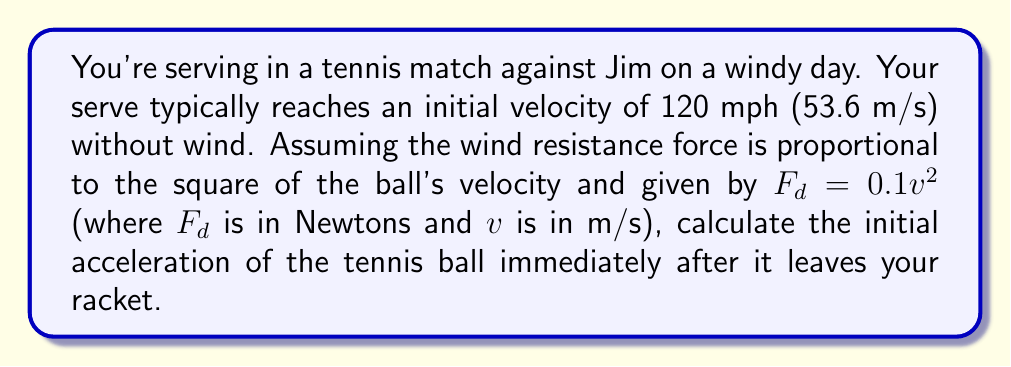Solve this math problem. To solve this problem, we'll follow these steps:

1) First, recall Newton's Second Law: $F = ma$

2) In this case, there are two forces acting on the ball:
   - The initial force of the serve ($F_s$)
   - The drag force due to wind resistance ($F_d$)

3) The net force is: $F_{net} = F_s - F_d$

4) We're given that $F_d = 0.1v^2$. At the initial moment, $v = 53.6$ m/s.

5) Calculate the initial drag force:
   $$F_d = 0.1 * (53.6)^2 = 287.296 \text{ N}$$

6) To find $F_s$, we need to consider the ball's mass and its acceleration without wind resistance. The mass of a tennis ball is approximately 58g or 0.058 kg.

   Without wind resistance, the initial acceleration would be enormous (assuming the force is applied over a very short time). Let's estimate it as 10,000 m/s². Then:

   $$F_s = ma = 0.058 * 10,000 = 580 \text{ N}$$

7) Now we can calculate the net force:
   $$F_{net} = 580 - 287.296 = 292.704 \text{ N}$$

8) Finally, we can calculate the initial acceleration with wind resistance:
   $$a = \frac{F_{net}}{m} = \frac{292.704}{0.058} = 5046.62 \text{ m/s²}$$
Answer: 5046.62 m/s² 